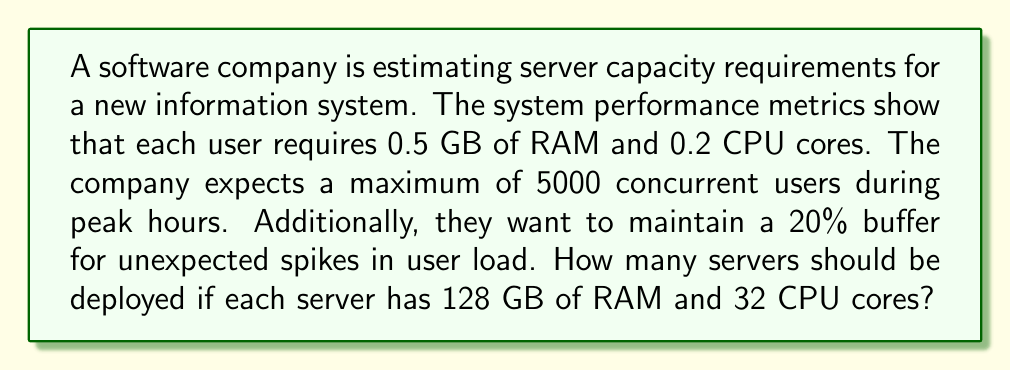Provide a solution to this math problem. Let's approach this problem step-by-step:

1. Calculate the total RAM required:
   $$\text{Total RAM} = \text{Users} \times \text{RAM per user} \times (1 + \text{Buffer})$$
   $$\text{Total RAM} = 5000 \times 0.5 \text{ GB} \times 1.2 = 3000 \text{ GB}$$

2. Calculate the total CPU cores required:
   $$\text{Total CPU cores} = \text{Users} \times \text{CPU cores per user} \times (1 + \text{Buffer})$$
   $$\text{Total CPU cores} = 5000 \times 0.2 \times 1.2 = 1200 \text{ cores}$$

3. Calculate the number of servers needed based on RAM:
   $$\text{Servers based on RAM} = \frac{\text{Total RAM}}{\text{RAM per server}}$$
   $$\text{Servers based on RAM} = \frac{3000 \text{ GB}}{128 \text{ GB}} = 23.4375$$

4. Calculate the number of servers needed based on CPU cores:
   $$\text{Servers based on CPU} = \frac{\text{Total CPU cores}}{\text{CPU cores per server}}$$
   $$\text{Servers based on CPU} = \frac{1200 \text{ cores}}{32 \text{ cores}} = 37.5$$

5. The number of servers needed is the ceiling of the maximum of these two values:
   $$\text{Servers needed} = \max(23.4375, 37.5) = 37.5$$

6. Round up to the nearest whole number:
   $$\text{Servers to deploy} = \lceil 37.5 \rceil = 38$$

Therefore, the company should deploy 38 servers to meet the estimated capacity requirements with the given buffer.
Answer: 38 servers 